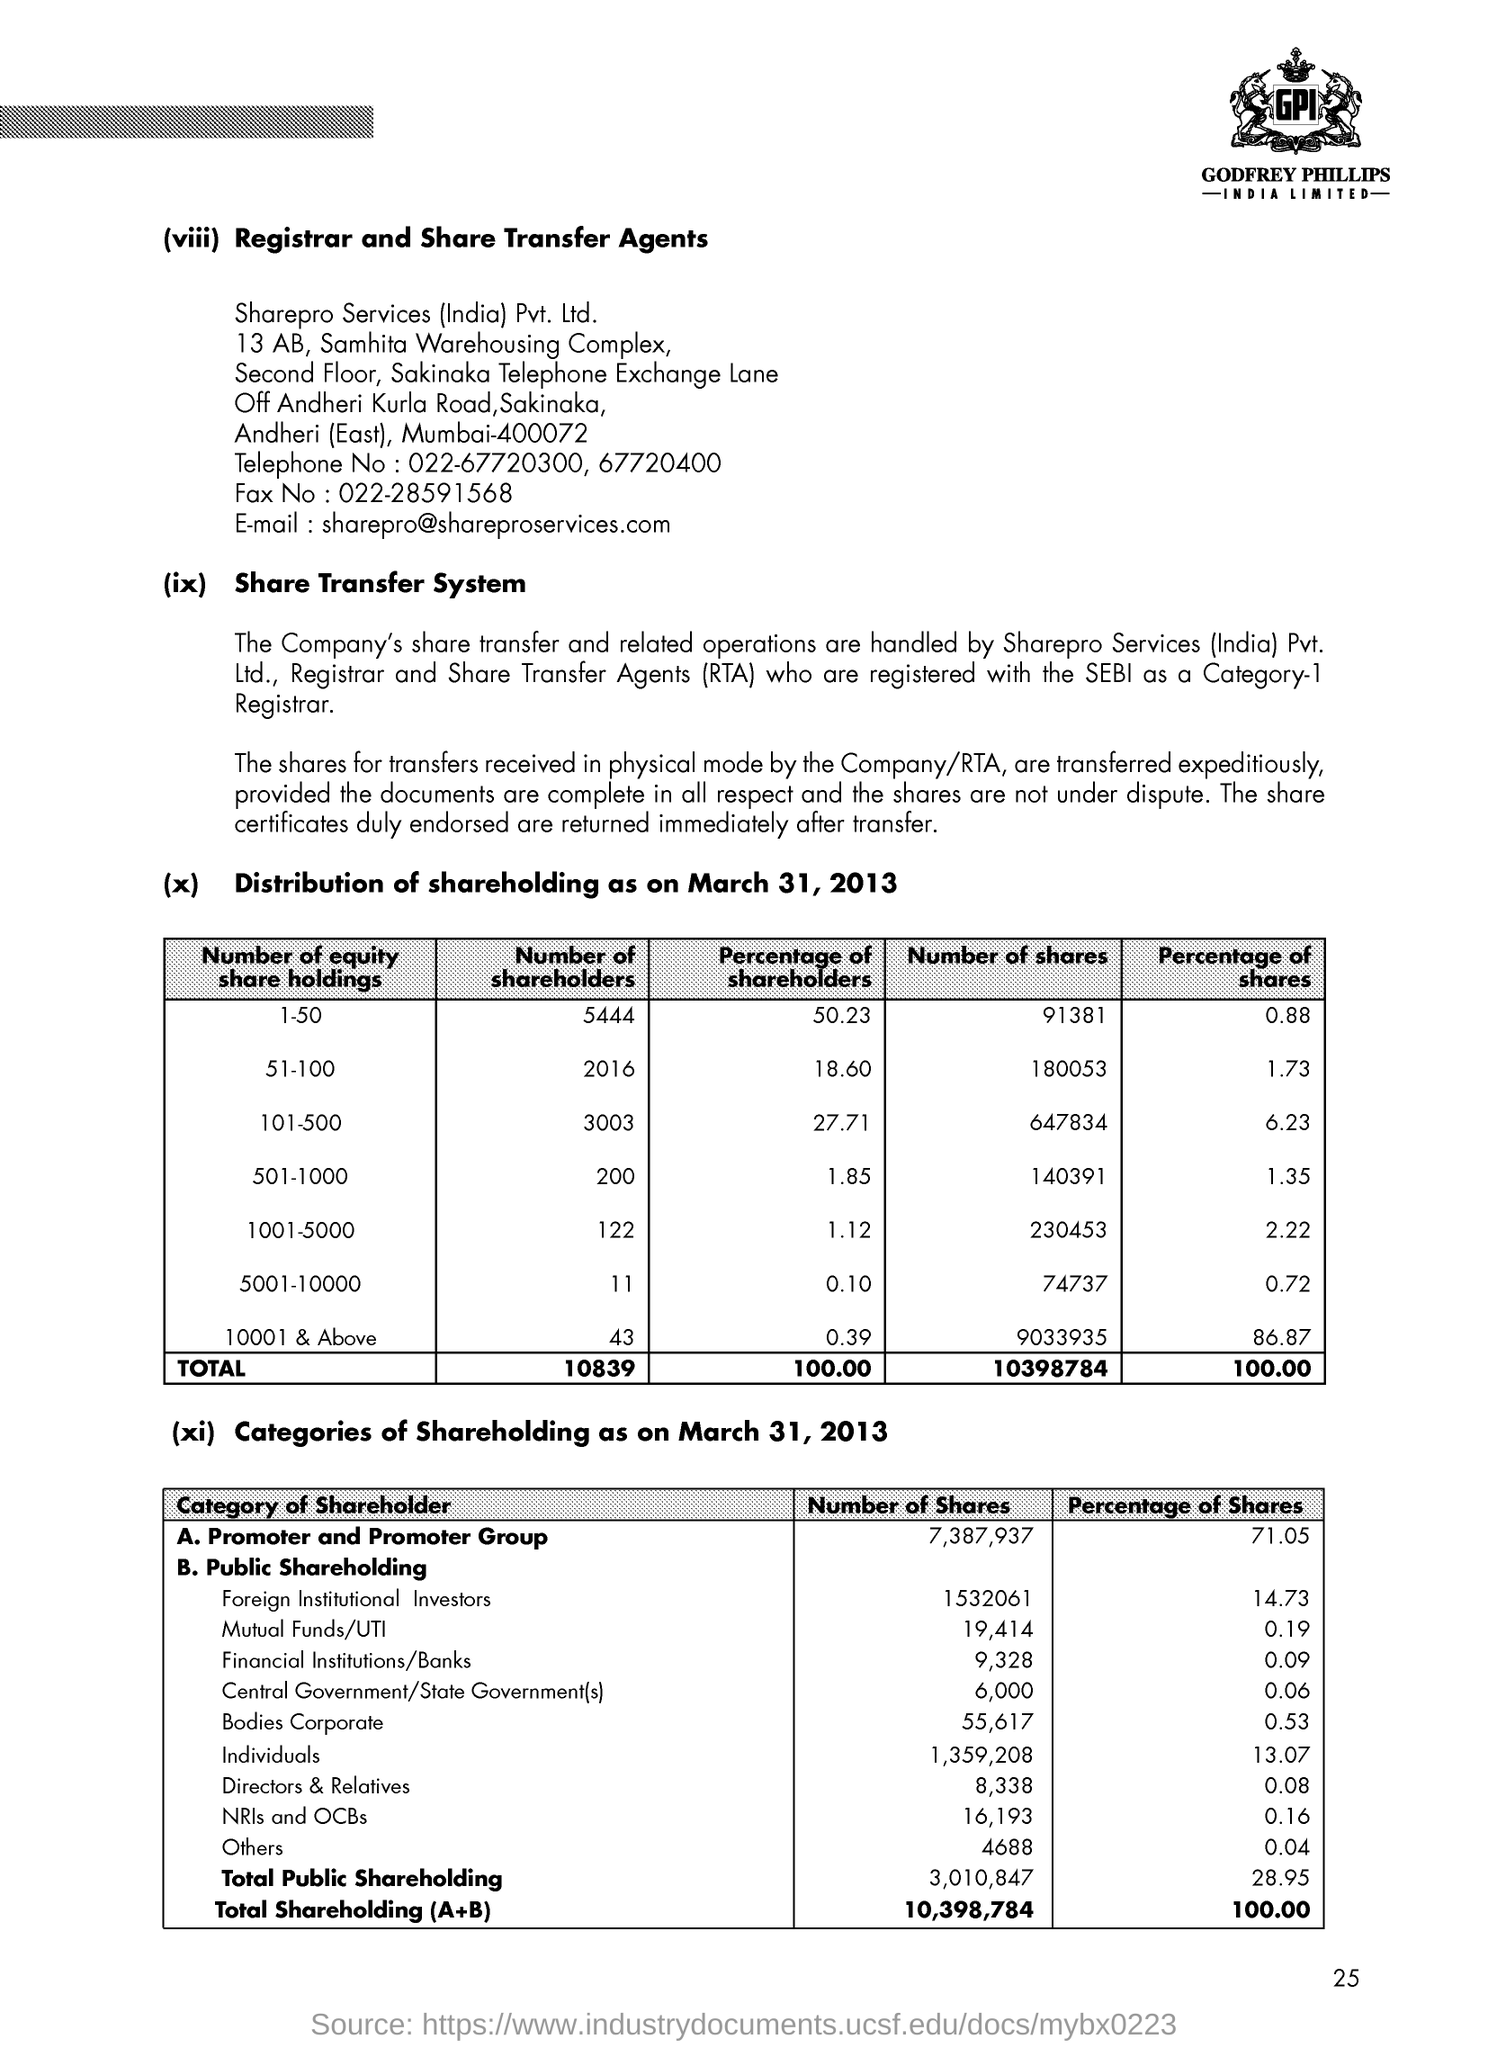What is the fullform of RTA?
Your answer should be very brief. Registrar and Share Transfer Agents. What is the Percentage of Shares held by Foreign Institutional Investors as on March 31, 2013?
Your answer should be very brief. 14.73. What is the No. of Shares held by NRIs and OCBs as on March 31, 2013?
Your answer should be very brief. 16,193. What is the Percentage of Shares held by Promoter and Promoter Group on March 31, 2013?
Keep it short and to the point. 71.05. What is the No. of Shares held by Promoter and Promoter Group as on March 31, 2013?
Your answer should be compact. 7,387,937. What is the page no mentioned in this document?
Your answer should be compact. 25. 